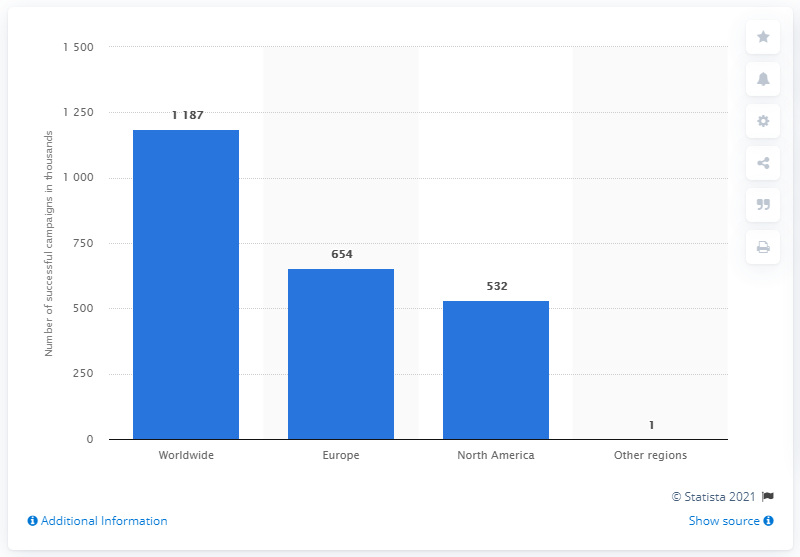List a handful of essential elements in this visual. In 2011, a total of 654 campaigns were run in Europe. 